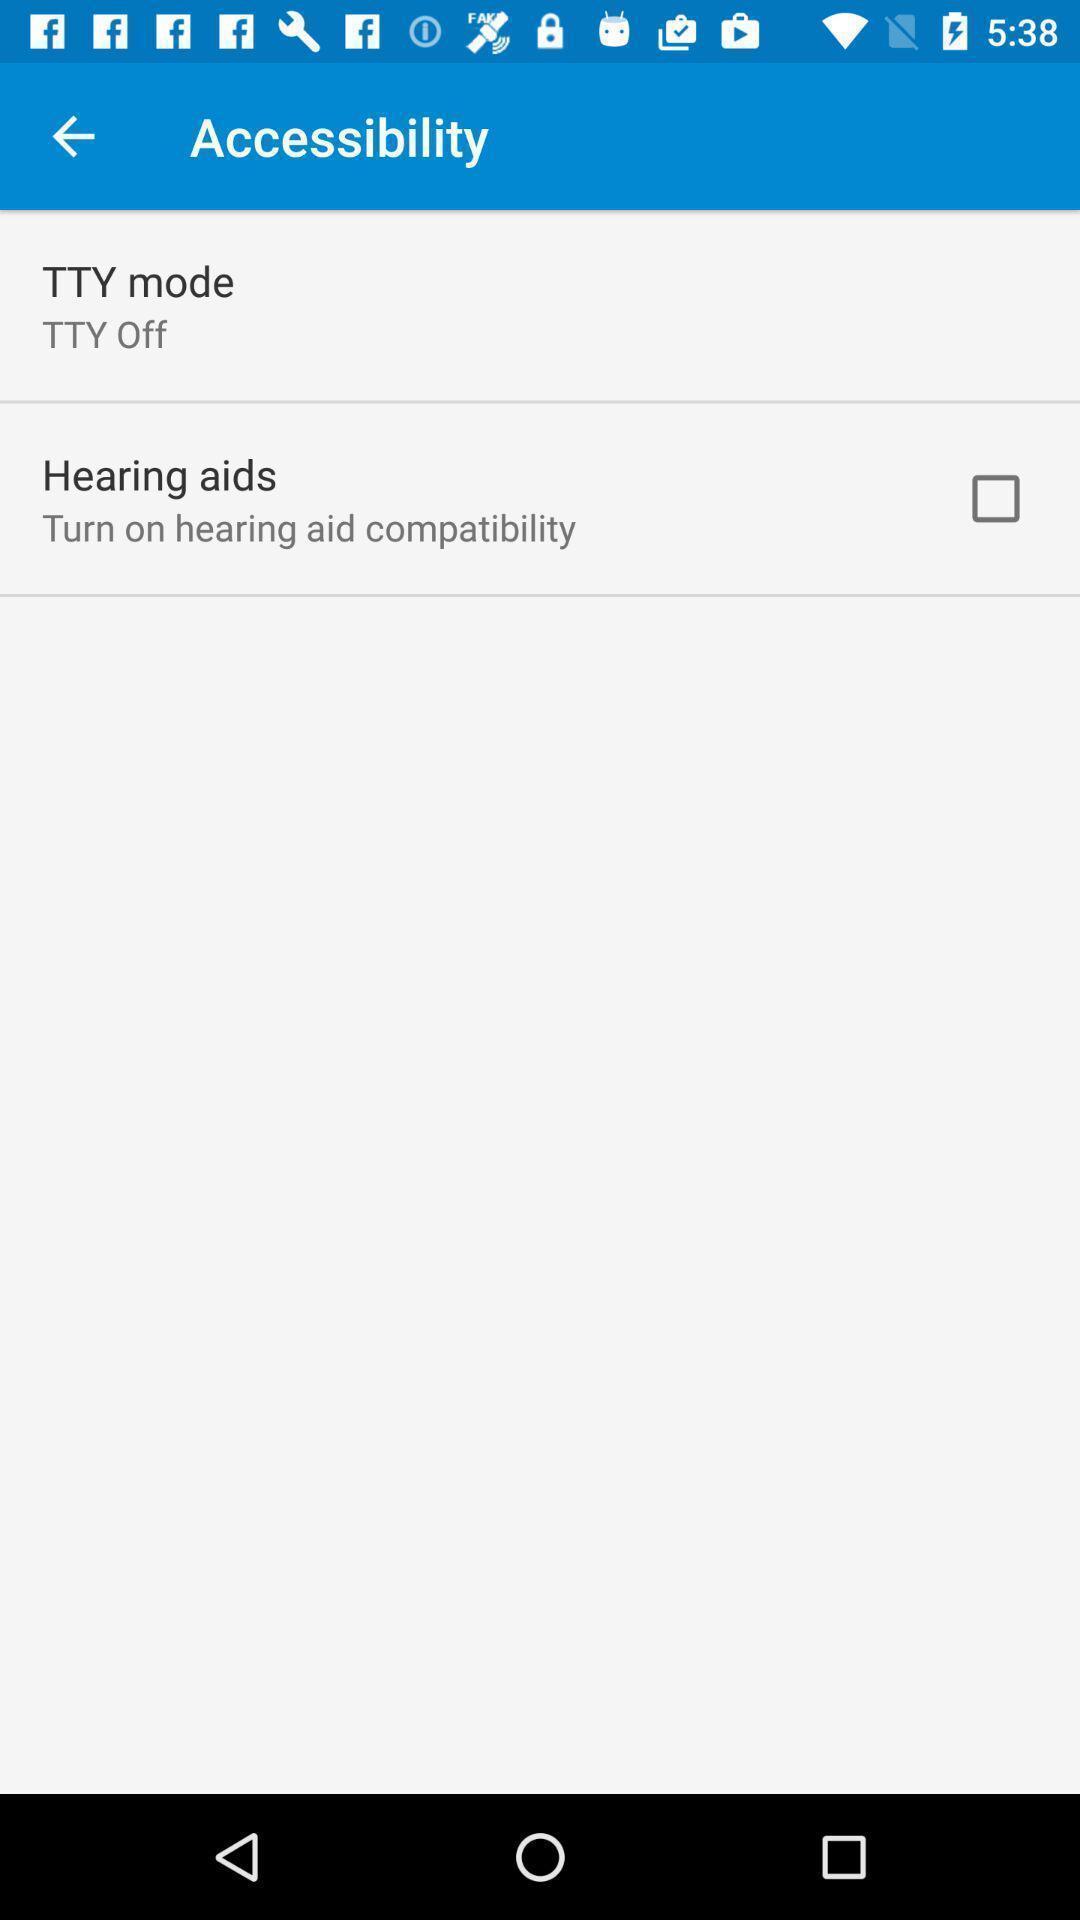Please provide a description for this image. Page displaying list of settings. 